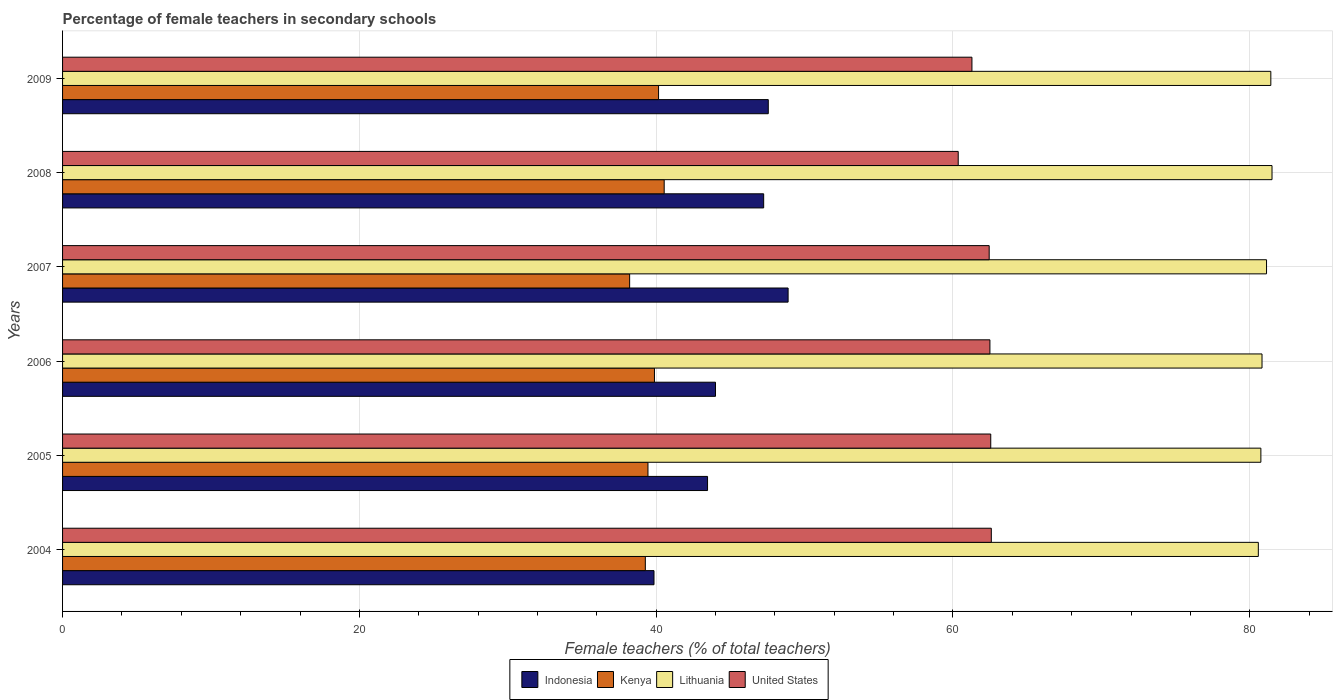How many groups of bars are there?
Give a very brief answer. 6. Are the number of bars per tick equal to the number of legend labels?
Provide a succinct answer. Yes. How many bars are there on the 4th tick from the top?
Your answer should be compact. 4. What is the label of the 1st group of bars from the top?
Provide a succinct answer. 2009. In how many cases, is the number of bars for a given year not equal to the number of legend labels?
Ensure brevity in your answer.  0. What is the percentage of female teachers in Lithuania in 2005?
Offer a terse response. 80.75. Across all years, what is the maximum percentage of female teachers in Lithuania?
Offer a terse response. 81.5. Across all years, what is the minimum percentage of female teachers in United States?
Your response must be concise. 60.36. In which year was the percentage of female teachers in Indonesia minimum?
Give a very brief answer. 2004. What is the total percentage of female teachers in Lithuania in the graph?
Make the answer very short. 486.22. What is the difference between the percentage of female teachers in Kenya in 2004 and that in 2007?
Provide a succinct answer. 1.06. What is the difference between the percentage of female teachers in Lithuania in 2006 and the percentage of female teachers in Indonesia in 2008?
Your response must be concise. 33.58. What is the average percentage of female teachers in Kenya per year?
Offer a terse response. 39.59. In the year 2009, what is the difference between the percentage of female teachers in Indonesia and percentage of female teachers in United States?
Make the answer very short. -13.72. What is the ratio of the percentage of female teachers in Kenya in 2006 to that in 2008?
Keep it short and to the point. 0.98. What is the difference between the highest and the second highest percentage of female teachers in Kenya?
Your answer should be compact. 0.38. What is the difference between the highest and the lowest percentage of female teachers in Lithuania?
Your answer should be compact. 0.92. In how many years, is the percentage of female teachers in Kenya greater than the average percentage of female teachers in Kenya taken over all years?
Provide a succinct answer. 3. Is the sum of the percentage of female teachers in Indonesia in 2007 and 2008 greater than the maximum percentage of female teachers in Kenya across all years?
Offer a very short reply. Yes. What does the 2nd bar from the top in 2009 represents?
Your answer should be compact. Lithuania. How many bars are there?
Offer a terse response. 24. Are all the bars in the graph horizontal?
Offer a terse response. Yes. How many years are there in the graph?
Your answer should be very brief. 6. Are the values on the major ticks of X-axis written in scientific E-notation?
Make the answer very short. No. Does the graph contain grids?
Keep it short and to the point. Yes. Where does the legend appear in the graph?
Offer a terse response. Bottom center. How are the legend labels stacked?
Provide a succinct answer. Horizontal. What is the title of the graph?
Make the answer very short. Percentage of female teachers in secondary schools. Does "Greenland" appear as one of the legend labels in the graph?
Provide a succinct answer. No. What is the label or title of the X-axis?
Your response must be concise. Female teachers (% of total teachers). What is the Female teachers (% of total teachers) in Indonesia in 2004?
Offer a very short reply. 39.86. What is the Female teachers (% of total teachers) in Kenya in 2004?
Your response must be concise. 39.27. What is the Female teachers (% of total teachers) in Lithuania in 2004?
Make the answer very short. 80.58. What is the Female teachers (% of total teachers) of United States in 2004?
Offer a very short reply. 62.59. What is the Female teachers (% of total teachers) of Indonesia in 2005?
Keep it short and to the point. 43.46. What is the Female teachers (% of total teachers) of Kenya in 2005?
Your answer should be compact. 39.45. What is the Female teachers (% of total teachers) in Lithuania in 2005?
Give a very brief answer. 80.75. What is the Female teachers (% of total teachers) of United States in 2005?
Your answer should be compact. 62.55. What is the Female teachers (% of total teachers) in Indonesia in 2006?
Ensure brevity in your answer.  44. What is the Female teachers (% of total teachers) of Kenya in 2006?
Give a very brief answer. 39.89. What is the Female teachers (% of total teachers) of Lithuania in 2006?
Make the answer very short. 80.83. What is the Female teachers (% of total teachers) of United States in 2006?
Provide a succinct answer. 62.49. What is the Female teachers (% of total teachers) of Indonesia in 2007?
Give a very brief answer. 48.89. What is the Female teachers (% of total teachers) of Kenya in 2007?
Your answer should be compact. 38.21. What is the Female teachers (% of total teachers) of Lithuania in 2007?
Ensure brevity in your answer.  81.13. What is the Female teachers (% of total teachers) of United States in 2007?
Keep it short and to the point. 62.44. What is the Female teachers (% of total teachers) in Indonesia in 2008?
Offer a very short reply. 47.25. What is the Female teachers (% of total teachers) in Kenya in 2008?
Give a very brief answer. 40.54. What is the Female teachers (% of total teachers) in Lithuania in 2008?
Provide a succinct answer. 81.5. What is the Female teachers (% of total teachers) in United States in 2008?
Keep it short and to the point. 60.36. What is the Female teachers (% of total teachers) in Indonesia in 2009?
Provide a succinct answer. 47.56. What is the Female teachers (% of total teachers) of Kenya in 2009?
Your answer should be very brief. 40.16. What is the Female teachers (% of total teachers) in Lithuania in 2009?
Offer a very short reply. 81.42. What is the Female teachers (% of total teachers) of United States in 2009?
Ensure brevity in your answer.  61.28. Across all years, what is the maximum Female teachers (% of total teachers) in Indonesia?
Your answer should be very brief. 48.89. Across all years, what is the maximum Female teachers (% of total teachers) of Kenya?
Provide a succinct answer. 40.54. Across all years, what is the maximum Female teachers (% of total teachers) in Lithuania?
Offer a terse response. 81.5. Across all years, what is the maximum Female teachers (% of total teachers) of United States?
Keep it short and to the point. 62.59. Across all years, what is the minimum Female teachers (% of total teachers) of Indonesia?
Offer a very short reply. 39.86. Across all years, what is the minimum Female teachers (% of total teachers) in Kenya?
Provide a short and direct response. 38.21. Across all years, what is the minimum Female teachers (% of total teachers) in Lithuania?
Your response must be concise. 80.58. Across all years, what is the minimum Female teachers (% of total teachers) in United States?
Provide a succinct answer. 60.36. What is the total Female teachers (% of total teachers) of Indonesia in the graph?
Your answer should be compact. 271.02. What is the total Female teachers (% of total teachers) of Kenya in the graph?
Offer a terse response. 237.53. What is the total Female teachers (% of total teachers) of Lithuania in the graph?
Ensure brevity in your answer.  486.22. What is the total Female teachers (% of total teachers) of United States in the graph?
Provide a succinct answer. 371.71. What is the difference between the Female teachers (% of total teachers) in Indonesia in 2004 and that in 2005?
Offer a terse response. -3.61. What is the difference between the Female teachers (% of total teachers) in Kenya in 2004 and that in 2005?
Provide a succinct answer. -0.18. What is the difference between the Female teachers (% of total teachers) in Lithuania in 2004 and that in 2005?
Offer a very short reply. -0.17. What is the difference between the Female teachers (% of total teachers) in United States in 2004 and that in 2005?
Offer a terse response. 0.04. What is the difference between the Female teachers (% of total teachers) in Indonesia in 2004 and that in 2006?
Your response must be concise. -4.14. What is the difference between the Female teachers (% of total teachers) of Kenya in 2004 and that in 2006?
Offer a very short reply. -0.61. What is the difference between the Female teachers (% of total teachers) in Lithuania in 2004 and that in 2006?
Your answer should be very brief. -0.25. What is the difference between the Female teachers (% of total teachers) of United States in 2004 and that in 2006?
Offer a very short reply. 0.09. What is the difference between the Female teachers (% of total teachers) of Indonesia in 2004 and that in 2007?
Your answer should be compact. -9.04. What is the difference between the Female teachers (% of total teachers) in Kenya in 2004 and that in 2007?
Offer a terse response. 1.06. What is the difference between the Female teachers (% of total teachers) in Lithuania in 2004 and that in 2007?
Ensure brevity in your answer.  -0.55. What is the difference between the Female teachers (% of total teachers) in United States in 2004 and that in 2007?
Make the answer very short. 0.14. What is the difference between the Female teachers (% of total teachers) of Indonesia in 2004 and that in 2008?
Make the answer very short. -7.39. What is the difference between the Female teachers (% of total teachers) of Kenya in 2004 and that in 2008?
Provide a succinct answer. -1.27. What is the difference between the Female teachers (% of total teachers) in Lithuania in 2004 and that in 2008?
Your answer should be very brief. -0.92. What is the difference between the Female teachers (% of total teachers) in United States in 2004 and that in 2008?
Offer a terse response. 2.23. What is the difference between the Female teachers (% of total teachers) in Indonesia in 2004 and that in 2009?
Give a very brief answer. -7.7. What is the difference between the Female teachers (% of total teachers) in Kenya in 2004 and that in 2009?
Offer a terse response. -0.89. What is the difference between the Female teachers (% of total teachers) of Lithuania in 2004 and that in 2009?
Offer a terse response. -0.84. What is the difference between the Female teachers (% of total teachers) in United States in 2004 and that in 2009?
Offer a very short reply. 1.31. What is the difference between the Female teachers (% of total teachers) in Indonesia in 2005 and that in 2006?
Give a very brief answer. -0.54. What is the difference between the Female teachers (% of total teachers) in Kenya in 2005 and that in 2006?
Your answer should be compact. -0.44. What is the difference between the Female teachers (% of total teachers) in Lithuania in 2005 and that in 2006?
Keep it short and to the point. -0.08. What is the difference between the Female teachers (% of total teachers) in United States in 2005 and that in 2006?
Ensure brevity in your answer.  0.06. What is the difference between the Female teachers (% of total teachers) of Indonesia in 2005 and that in 2007?
Your response must be concise. -5.43. What is the difference between the Female teachers (% of total teachers) in Kenya in 2005 and that in 2007?
Your response must be concise. 1.24. What is the difference between the Female teachers (% of total teachers) in Lithuania in 2005 and that in 2007?
Ensure brevity in your answer.  -0.38. What is the difference between the Female teachers (% of total teachers) in United States in 2005 and that in 2007?
Make the answer very short. 0.1. What is the difference between the Female teachers (% of total teachers) in Indonesia in 2005 and that in 2008?
Give a very brief answer. -3.78. What is the difference between the Female teachers (% of total teachers) in Kenya in 2005 and that in 2008?
Your response must be concise. -1.09. What is the difference between the Female teachers (% of total teachers) of Lithuania in 2005 and that in 2008?
Provide a succinct answer. -0.75. What is the difference between the Female teachers (% of total teachers) in United States in 2005 and that in 2008?
Your answer should be very brief. 2.19. What is the difference between the Female teachers (% of total teachers) of Indonesia in 2005 and that in 2009?
Your answer should be very brief. -4.09. What is the difference between the Female teachers (% of total teachers) of Kenya in 2005 and that in 2009?
Provide a succinct answer. -0.71. What is the difference between the Female teachers (% of total teachers) of Lithuania in 2005 and that in 2009?
Ensure brevity in your answer.  -0.67. What is the difference between the Female teachers (% of total teachers) of United States in 2005 and that in 2009?
Your answer should be very brief. 1.27. What is the difference between the Female teachers (% of total teachers) of Indonesia in 2006 and that in 2007?
Give a very brief answer. -4.89. What is the difference between the Female teachers (% of total teachers) in Kenya in 2006 and that in 2007?
Provide a short and direct response. 1.67. What is the difference between the Female teachers (% of total teachers) of Lithuania in 2006 and that in 2007?
Your answer should be very brief. -0.3. What is the difference between the Female teachers (% of total teachers) in United States in 2006 and that in 2007?
Your response must be concise. 0.05. What is the difference between the Female teachers (% of total teachers) of Indonesia in 2006 and that in 2008?
Your answer should be compact. -3.25. What is the difference between the Female teachers (% of total teachers) in Kenya in 2006 and that in 2008?
Offer a very short reply. -0.66. What is the difference between the Female teachers (% of total teachers) of Lithuania in 2006 and that in 2008?
Your answer should be compact. -0.67. What is the difference between the Female teachers (% of total teachers) in United States in 2006 and that in 2008?
Ensure brevity in your answer.  2.14. What is the difference between the Female teachers (% of total teachers) of Indonesia in 2006 and that in 2009?
Provide a short and direct response. -3.56. What is the difference between the Female teachers (% of total teachers) in Kenya in 2006 and that in 2009?
Keep it short and to the point. -0.28. What is the difference between the Female teachers (% of total teachers) in Lithuania in 2006 and that in 2009?
Keep it short and to the point. -0.59. What is the difference between the Female teachers (% of total teachers) in United States in 2006 and that in 2009?
Your answer should be compact. 1.21. What is the difference between the Female teachers (% of total teachers) in Indonesia in 2007 and that in 2008?
Make the answer very short. 1.65. What is the difference between the Female teachers (% of total teachers) of Kenya in 2007 and that in 2008?
Keep it short and to the point. -2.33. What is the difference between the Female teachers (% of total teachers) in Lithuania in 2007 and that in 2008?
Provide a succinct answer. -0.37. What is the difference between the Female teachers (% of total teachers) of United States in 2007 and that in 2008?
Make the answer very short. 2.09. What is the difference between the Female teachers (% of total teachers) of Indonesia in 2007 and that in 2009?
Provide a short and direct response. 1.34. What is the difference between the Female teachers (% of total teachers) of Kenya in 2007 and that in 2009?
Your response must be concise. -1.95. What is the difference between the Female teachers (% of total teachers) of Lithuania in 2007 and that in 2009?
Ensure brevity in your answer.  -0.29. What is the difference between the Female teachers (% of total teachers) in United States in 2007 and that in 2009?
Offer a very short reply. 1.16. What is the difference between the Female teachers (% of total teachers) of Indonesia in 2008 and that in 2009?
Keep it short and to the point. -0.31. What is the difference between the Female teachers (% of total teachers) of Kenya in 2008 and that in 2009?
Offer a terse response. 0.38. What is the difference between the Female teachers (% of total teachers) in Lithuania in 2008 and that in 2009?
Offer a terse response. 0.08. What is the difference between the Female teachers (% of total teachers) in United States in 2008 and that in 2009?
Your answer should be very brief. -0.93. What is the difference between the Female teachers (% of total teachers) of Indonesia in 2004 and the Female teachers (% of total teachers) of Kenya in 2005?
Your response must be concise. 0.41. What is the difference between the Female teachers (% of total teachers) of Indonesia in 2004 and the Female teachers (% of total teachers) of Lithuania in 2005?
Provide a short and direct response. -40.9. What is the difference between the Female teachers (% of total teachers) in Indonesia in 2004 and the Female teachers (% of total teachers) in United States in 2005?
Your answer should be very brief. -22.69. What is the difference between the Female teachers (% of total teachers) of Kenya in 2004 and the Female teachers (% of total teachers) of Lithuania in 2005?
Make the answer very short. -41.48. What is the difference between the Female teachers (% of total teachers) of Kenya in 2004 and the Female teachers (% of total teachers) of United States in 2005?
Provide a short and direct response. -23.28. What is the difference between the Female teachers (% of total teachers) of Lithuania in 2004 and the Female teachers (% of total teachers) of United States in 2005?
Make the answer very short. 18.03. What is the difference between the Female teachers (% of total teachers) in Indonesia in 2004 and the Female teachers (% of total teachers) in Kenya in 2006?
Keep it short and to the point. -0.03. What is the difference between the Female teachers (% of total teachers) of Indonesia in 2004 and the Female teachers (% of total teachers) of Lithuania in 2006?
Ensure brevity in your answer.  -40.97. What is the difference between the Female teachers (% of total teachers) of Indonesia in 2004 and the Female teachers (% of total teachers) of United States in 2006?
Offer a very short reply. -22.64. What is the difference between the Female teachers (% of total teachers) of Kenya in 2004 and the Female teachers (% of total teachers) of Lithuania in 2006?
Make the answer very short. -41.56. What is the difference between the Female teachers (% of total teachers) of Kenya in 2004 and the Female teachers (% of total teachers) of United States in 2006?
Your answer should be compact. -23.22. What is the difference between the Female teachers (% of total teachers) of Lithuania in 2004 and the Female teachers (% of total teachers) of United States in 2006?
Your response must be concise. 18.09. What is the difference between the Female teachers (% of total teachers) of Indonesia in 2004 and the Female teachers (% of total teachers) of Kenya in 2007?
Give a very brief answer. 1.64. What is the difference between the Female teachers (% of total teachers) in Indonesia in 2004 and the Female teachers (% of total teachers) in Lithuania in 2007?
Offer a terse response. -41.28. What is the difference between the Female teachers (% of total teachers) in Indonesia in 2004 and the Female teachers (% of total teachers) in United States in 2007?
Your answer should be compact. -22.59. What is the difference between the Female teachers (% of total teachers) in Kenya in 2004 and the Female teachers (% of total teachers) in Lithuania in 2007?
Provide a succinct answer. -41.86. What is the difference between the Female teachers (% of total teachers) in Kenya in 2004 and the Female teachers (% of total teachers) in United States in 2007?
Offer a very short reply. -23.17. What is the difference between the Female teachers (% of total teachers) in Lithuania in 2004 and the Female teachers (% of total teachers) in United States in 2007?
Offer a terse response. 18.14. What is the difference between the Female teachers (% of total teachers) in Indonesia in 2004 and the Female teachers (% of total teachers) in Kenya in 2008?
Give a very brief answer. -0.69. What is the difference between the Female teachers (% of total teachers) of Indonesia in 2004 and the Female teachers (% of total teachers) of Lithuania in 2008?
Offer a very short reply. -41.65. What is the difference between the Female teachers (% of total teachers) of Indonesia in 2004 and the Female teachers (% of total teachers) of United States in 2008?
Your answer should be compact. -20.5. What is the difference between the Female teachers (% of total teachers) of Kenya in 2004 and the Female teachers (% of total teachers) of Lithuania in 2008?
Offer a terse response. -42.23. What is the difference between the Female teachers (% of total teachers) of Kenya in 2004 and the Female teachers (% of total teachers) of United States in 2008?
Keep it short and to the point. -21.09. What is the difference between the Female teachers (% of total teachers) in Lithuania in 2004 and the Female teachers (% of total teachers) in United States in 2008?
Offer a terse response. 20.22. What is the difference between the Female teachers (% of total teachers) of Indonesia in 2004 and the Female teachers (% of total teachers) of Kenya in 2009?
Your response must be concise. -0.31. What is the difference between the Female teachers (% of total teachers) in Indonesia in 2004 and the Female teachers (% of total teachers) in Lithuania in 2009?
Provide a succinct answer. -41.57. What is the difference between the Female teachers (% of total teachers) of Indonesia in 2004 and the Female teachers (% of total teachers) of United States in 2009?
Provide a short and direct response. -21.43. What is the difference between the Female teachers (% of total teachers) of Kenya in 2004 and the Female teachers (% of total teachers) of Lithuania in 2009?
Ensure brevity in your answer.  -42.15. What is the difference between the Female teachers (% of total teachers) in Kenya in 2004 and the Female teachers (% of total teachers) in United States in 2009?
Your answer should be compact. -22.01. What is the difference between the Female teachers (% of total teachers) of Lithuania in 2004 and the Female teachers (% of total teachers) of United States in 2009?
Offer a very short reply. 19.3. What is the difference between the Female teachers (% of total teachers) of Indonesia in 2005 and the Female teachers (% of total teachers) of Kenya in 2006?
Ensure brevity in your answer.  3.58. What is the difference between the Female teachers (% of total teachers) of Indonesia in 2005 and the Female teachers (% of total teachers) of Lithuania in 2006?
Provide a succinct answer. -37.36. What is the difference between the Female teachers (% of total teachers) of Indonesia in 2005 and the Female teachers (% of total teachers) of United States in 2006?
Give a very brief answer. -19.03. What is the difference between the Female teachers (% of total teachers) in Kenya in 2005 and the Female teachers (% of total teachers) in Lithuania in 2006?
Provide a short and direct response. -41.38. What is the difference between the Female teachers (% of total teachers) of Kenya in 2005 and the Female teachers (% of total teachers) of United States in 2006?
Provide a short and direct response. -23.04. What is the difference between the Female teachers (% of total teachers) in Lithuania in 2005 and the Female teachers (% of total teachers) in United States in 2006?
Provide a succinct answer. 18.26. What is the difference between the Female teachers (% of total teachers) in Indonesia in 2005 and the Female teachers (% of total teachers) in Kenya in 2007?
Ensure brevity in your answer.  5.25. What is the difference between the Female teachers (% of total teachers) of Indonesia in 2005 and the Female teachers (% of total teachers) of Lithuania in 2007?
Your response must be concise. -37.67. What is the difference between the Female teachers (% of total teachers) of Indonesia in 2005 and the Female teachers (% of total teachers) of United States in 2007?
Keep it short and to the point. -18.98. What is the difference between the Female teachers (% of total teachers) in Kenya in 2005 and the Female teachers (% of total teachers) in Lithuania in 2007?
Provide a short and direct response. -41.68. What is the difference between the Female teachers (% of total teachers) of Kenya in 2005 and the Female teachers (% of total teachers) of United States in 2007?
Provide a short and direct response. -22.99. What is the difference between the Female teachers (% of total teachers) in Lithuania in 2005 and the Female teachers (% of total teachers) in United States in 2007?
Make the answer very short. 18.31. What is the difference between the Female teachers (% of total teachers) in Indonesia in 2005 and the Female teachers (% of total teachers) in Kenya in 2008?
Provide a short and direct response. 2.92. What is the difference between the Female teachers (% of total teachers) of Indonesia in 2005 and the Female teachers (% of total teachers) of Lithuania in 2008?
Provide a succinct answer. -38.04. What is the difference between the Female teachers (% of total teachers) in Indonesia in 2005 and the Female teachers (% of total teachers) in United States in 2008?
Offer a terse response. -16.89. What is the difference between the Female teachers (% of total teachers) of Kenya in 2005 and the Female teachers (% of total teachers) of Lithuania in 2008?
Your answer should be compact. -42.05. What is the difference between the Female teachers (% of total teachers) in Kenya in 2005 and the Female teachers (% of total teachers) in United States in 2008?
Offer a very short reply. -20.91. What is the difference between the Female teachers (% of total teachers) of Lithuania in 2005 and the Female teachers (% of total teachers) of United States in 2008?
Make the answer very short. 20.4. What is the difference between the Female teachers (% of total teachers) in Indonesia in 2005 and the Female teachers (% of total teachers) in Kenya in 2009?
Keep it short and to the point. 3.3. What is the difference between the Female teachers (% of total teachers) in Indonesia in 2005 and the Female teachers (% of total teachers) in Lithuania in 2009?
Give a very brief answer. -37.96. What is the difference between the Female teachers (% of total teachers) of Indonesia in 2005 and the Female teachers (% of total teachers) of United States in 2009?
Provide a short and direct response. -17.82. What is the difference between the Female teachers (% of total teachers) of Kenya in 2005 and the Female teachers (% of total teachers) of Lithuania in 2009?
Your answer should be very brief. -41.97. What is the difference between the Female teachers (% of total teachers) in Kenya in 2005 and the Female teachers (% of total teachers) in United States in 2009?
Offer a very short reply. -21.83. What is the difference between the Female teachers (% of total teachers) of Lithuania in 2005 and the Female teachers (% of total teachers) of United States in 2009?
Your answer should be very brief. 19.47. What is the difference between the Female teachers (% of total teachers) in Indonesia in 2006 and the Female teachers (% of total teachers) in Kenya in 2007?
Your response must be concise. 5.79. What is the difference between the Female teachers (% of total teachers) of Indonesia in 2006 and the Female teachers (% of total teachers) of Lithuania in 2007?
Give a very brief answer. -37.13. What is the difference between the Female teachers (% of total teachers) in Indonesia in 2006 and the Female teachers (% of total teachers) in United States in 2007?
Make the answer very short. -18.44. What is the difference between the Female teachers (% of total teachers) in Kenya in 2006 and the Female teachers (% of total teachers) in Lithuania in 2007?
Provide a succinct answer. -41.25. What is the difference between the Female teachers (% of total teachers) of Kenya in 2006 and the Female teachers (% of total teachers) of United States in 2007?
Provide a succinct answer. -22.56. What is the difference between the Female teachers (% of total teachers) in Lithuania in 2006 and the Female teachers (% of total teachers) in United States in 2007?
Your answer should be very brief. 18.38. What is the difference between the Female teachers (% of total teachers) of Indonesia in 2006 and the Female teachers (% of total teachers) of Kenya in 2008?
Keep it short and to the point. 3.46. What is the difference between the Female teachers (% of total teachers) of Indonesia in 2006 and the Female teachers (% of total teachers) of Lithuania in 2008?
Provide a short and direct response. -37.5. What is the difference between the Female teachers (% of total teachers) of Indonesia in 2006 and the Female teachers (% of total teachers) of United States in 2008?
Offer a terse response. -16.36. What is the difference between the Female teachers (% of total teachers) in Kenya in 2006 and the Female teachers (% of total teachers) in Lithuania in 2008?
Your answer should be compact. -41.62. What is the difference between the Female teachers (% of total teachers) in Kenya in 2006 and the Female teachers (% of total teachers) in United States in 2008?
Offer a very short reply. -20.47. What is the difference between the Female teachers (% of total teachers) of Lithuania in 2006 and the Female teachers (% of total teachers) of United States in 2008?
Make the answer very short. 20.47. What is the difference between the Female teachers (% of total teachers) in Indonesia in 2006 and the Female teachers (% of total teachers) in Kenya in 2009?
Provide a short and direct response. 3.84. What is the difference between the Female teachers (% of total teachers) in Indonesia in 2006 and the Female teachers (% of total teachers) in Lithuania in 2009?
Make the answer very short. -37.42. What is the difference between the Female teachers (% of total teachers) in Indonesia in 2006 and the Female teachers (% of total teachers) in United States in 2009?
Make the answer very short. -17.28. What is the difference between the Female teachers (% of total teachers) of Kenya in 2006 and the Female teachers (% of total teachers) of Lithuania in 2009?
Make the answer very short. -41.54. What is the difference between the Female teachers (% of total teachers) in Kenya in 2006 and the Female teachers (% of total teachers) in United States in 2009?
Give a very brief answer. -21.4. What is the difference between the Female teachers (% of total teachers) in Lithuania in 2006 and the Female teachers (% of total teachers) in United States in 2009?
Your response must be concise. 19.55. What is the difference between the Female teachers (% of total teachers) in Indonesia in 2007 and the Female teachers (% of total teachers) in Kenya in 2008?
Offer a terse response. 8.35. What is the difference between the Female teachers (% of total teachers) of Indonesia in 2007 and the Female teachers (% of total teachers) of Lithuania in 2008?
Your answer should be very brief. -32.61. What is the difference between the Female teachers (% of total teachers) in Indonesia in 2007 and the Female teachers (% of total teachers) in United States in 2008?
Ensure brevity in your answer.  -11.46. What is the difference between the Female teachers (% of total teachers) of Kenya in 2007 and the Female teachers (% of total teachers) of Lithuania in 2008?
Your answer should be compact. -43.29. What is the difference between the Female teachers (% of total teachers) of Kenya in 2007 and the Female teachers (% of total teachers) of United States in 2008?
Your response must be concise. -22.14. What is the difference between the Female teachers (% of total teachers) of Lithuania in 2007 and the Female teachers (% of total teachers) of United States in 2008?
Your answer should be compact. 20.78. What is the difference between the Female teachers (% of total teachers) of Indonesia in 2007 and the Female teachers (% of total teachers) of Kenya in 2009?
Offer a very short reply. 8.73. What is the difference between the Female teachers (% of total teachers) of Indonesia in 2007 and the Female teachers (% of total teachers) of Lithuania in 2009?
Give a very brief answer. -32.53. What is the difference between the Female teachers (% of total teachers) in Indonesia in 2007 and the Female teachers (% of total teachers) in United States in 2009?
Give a very brief answer. -12.39. What is the difference between the Female teachers (% of total teachers) in Kenya in 2007 and the Female teachers (% of total teachers) in Lithuania in 2009?
Provide a succinct answer. -43.21. What is the difference between the Female teachers (% of total teachers) in Kenya in 2007 and the Female teachers (% of total teachers) in United States in 2009?
Your answer should be compact. -23.07. What is the difference between the Female teachers (% of total teachers) in Lithuania in 2007 and the Female teachers (% of total teachers) in United States in 2009?
Give a very brief answer. 19.85. What is the difference between the Female teachers (% of total teachers) of Indonesia in 2008 and the Female teachers (% of total teachers) of Kenya in 2009?
Make the answer very short. 7.08. What is the difference between the Female teachers (% of total teachers) in Indonesia in 2008 and the Female teachers (% of total teachers) in Lithuania in 2009?
Your response must be concise. -34.18. What is the difference between the Female teachers (% of total teachers) in Indonesia in 2008 and the Female teachers (% of total teachers) in United States in 2009?
Provide a succinct answer. -14.03. What is the difference between the Female teachers (% of total teachers) in Kenya in 2008 and the Female teachers (% of total teachers) in Lithuania in 2009?
Your response must be concise. -40.88. What is the difference between the Female teachers (% of total teachers) in Kenya in 2008 and the Female teachers (% of total teachers) in United States in 2009?
Keep it short and to the point. -20.74. What is the difference between the Female teachers (% of total teachers) of Lithuania in 2008 and the Female teachers (% of total teachers) of United States in 2009?
Keep it short and to the point. 20.22. What is the average Female teachers (% of total teachers) of Indonesia per year?
Your answer should be compact. 45.17. What is the average Female teachers (% of total teachers) of Kenya per year?
Ensure brevity in your answer.  39.59. What is the average Female teachers (% of total teachers) of Lithuania per year?
Provide a succinct answer. 81.04. What is the average Female teachers (% of total teachers) in United States per year?
Offer a terse response. 61.95. In the year 2004, what is the difference between the Female teachers (% of total teachers) in Indonesia and Female teachers (% of total teachers) in Kenya?
Your answer should be compact. 0.58. In the year 2004, what is the difference between the Female teachers (% of total teachers) of Indonesia and Female teachers (% of total teachers) of Lithuania?
Your answer should be compact. -40.73. In the year 2004, what is the difference between the Female teachers (% of total teachers) in Indonesia and Female teachers (% of total teachers) in United States?
Your response must be concise. -22.73. In the year 2004, what is the difference between the Female teachers (% of total teachers) in Kenya and Female teachers (% of total teachers) in Lithuania?
Your answer should be very brief. -41.31. In the year 2004, what is the difference between the Female teachers (% of total teachers) of Kenya and Female teachers (% of total teachers) of United States?
Your answer should be very brief. -23.32. In the year 2004, what is the difference between the Female teachers (% of total teachers) of Lithuania and Female teachers (% of total teachers) of United States?
Give a very brief answer. 17.99. In the year 2005, what is the difference between the Female teachers (% of total teachers) in Indonesia and Female teachers (% of total teachers) in Kenya?
Your response must be concise. 4.01. In the year 2005, what is the difference between the Female teachers (% of total teachers) in Indonesia and Female teachers (% of total teachers) in Lithuania?
Offer a very short reply. -37.29. In the year 2005, what is the difference between the Female teachers (% of total teachers) in Indonesia and Female teachers (% of total teachers) in United States?
Ensure brevity in your answer.  -19.08. In the year 2005, what is the difference between the Female teachers (% of total teachers) of Kenya and Female teachers (% of total teachers) of Lithuania?
Your answer should be compact. -41.3. In the year 2005, what is the difference between the Female teachers (% of total teachers) of Kenya and Female teachers (% of total teachers) of United States?
Provide a short and direct response. -23.1. In the year 2005, what is the difference between the Female teachers (% of total teachers) of Lithuania and Female teachers (% of total teachers) of United States?
Make the answer very short. 18.2. In the year 2006, what is the difference between the Female teachers (% of total teachers) of Indonesia and Female teachers (% of total teachers) of Kenya?
Your answer should be compact. 4.11. In the year 2006, what is the difference between the Female teachers (% of total teachers) in Indonesia and Female teachers (% of total teachers) in Lithuania?
Your answer should be very brief. -36.83. In the year 2006, what is the difference between the Female teachers (% of total teachers) in Indonesia and Female teachers (% of total teachers) in United States?
Provide a short and direct response. -18.49. In the year 2006, what is the difference between the Female teachers (% of total teachers) of Kenya and Female teachers (% of total teachers) of Lithuania?
Provide a short and direct response. -40.94. In the year 2006, what is the difference between the Female teachers (% of total teachers) of Kenya and Female teachers (% of total teachers) of United States?
Ensure brevity in your answer.  -22.61. In the year 2006, what is the difference between the Female teachers (% of total teachers) of Lithuania and Female teachers (% of total teachers) of United States?
Make the answer very short. 18.34. In the year 2007, what is the difference between the Female teachers (% of total teachers) of Indonesia and Female teachers (% of total teachers) of Kenya?
Give a very brief answer. 10.68. In the year 2007, what is the difference between the Female teachers (% of total teachers) in Indonesia and Female teachers (% of total teachers) in Lithuania?
Provide a succinct answer. -32.24. In the year 2007, what is the difference between the Female teachers (% of total teachers) in Indonesia and Female teachers (% of total teachers) in United States?
Your response must be concise. -13.55. In the year 2007, what is the difference between the Female teachers (% of total teachers) in Kenya and Female teachers (% of total teachers) in Lithuania?
Provide a succinct answer. -42.92. In the year 2007, what is the difference between the Female teachers (% of total teachers) in Kenya and Female teachers (% of total teachers) in United States?
Offer a terse response. -24.23. In the year 2007, what is the difference between the Female teachers (% of total teachers) in Lithuania and Female teachers (% of total teachers) in United States?
Your answer should be very brief. 18.69. In the year 2008, what is the difference between the Female teachers (% of total teachers) of Indonesia and Female teachers (% of total teachers) of Kenya?
Ensure brevity in your answer.  6.7. In the year 2008, what is the difference between the Female teachers (% of total teachers) of Indonesia and Female teachers (% of total teachers) of Lithuania?
Your response must be concise. -34.26. In the year 2008, what is the difference between the Female teachers (% of total teachers) of Indonesia and Female teachers (% of total teachers) of United States?
Your response must be concise. -13.11. In the year 2008, what is the difference between the Female teachers (% of total teachers) of Kenya and Female teachers (% of total teachers) of Lithuania?
Ensure brevity in your answer.  -40.96. In the year 2008, what is the difference between the Female teachers (% of total teachers) of Kenya and Female teachers (% of total teachers) of United States?
Provide a succinct answer. -19.81. In the year 2008, what is the difference between the Female teachers (% of total teachers) in Lithuania and Female teachers (% of total teachers) in United States?
Your response must be concise. 21.15. In the year 2009, what is the difference between the Female teachers (% of total teachers) of Indonesia and Female teachers (% of total teachers) of Kenya?
Your answer should be compact. 7.39. In the year 2009, what is the difference between the Female teachers (% of total teachers) of Indonesia and Female teachers (% of total teachers) of Lithuania?
Your answer should be very brief. -33.87. In the year 2009, what is the difference between the Female teachers (% of total teachers) of Indonesia and Female teachers (% of total teachers) of United States?
Ensure brevity in your answer.  -13.72. In the year 2009, what is the difference between the Female teachers (% of total teachers) in Kenya and Female teachers (% of total teachers) in Lithuania?
Offer a terse response. -41.26. In the year 2009, what is the difference between the Female teachers (% of total teachers) in Kenya and Female teachers (% of total teachers) in United States?
Ensure brevity in your answer.  -21.12. In the year 2009, what is the difference between the Female teachers (% of total teachers) of Lithuania and Female teachers (% of total teachers) of United States?
Provide a succinct answer. 20.14. What is the ratio of the Female teachers (% of total teachers) in Indonesia in 2004 to that in 2005?
Make the answer very short. 0.92. What is the ratio of the Female teachers (% of total teachers) in Indonesia in 2004 to that in 2006?
Ensure brevity in your answer.  0.91. What is the ratio of the Female teachers (% of total teachers) of Kenya in 2004 to that in 2006?
Provide a short and direct response. 0.98. What is the ratio of the Female teachers (% of total teachers) in Lithuania in 2004 to that in 2006?
Provide a succinct answer. 1. What is the ratio of the Female teachers (% of total teachers) of United States in 2004 to that in 2006?
Make the answer very short. 1. What is the ratio of the Female teachers (% of total teachers) in Indonesia in 2004 to that in 2007?
Provide a short and direct response. 0.82. What is the ratio of the Female teachers (% of total teachers) of Kenya in 2004 to that in 2007?
Offer a very short reply. 1.03. What is the ratio of the Female teachers (% of total teachers) in Lithuania in 2004 to that in 2007?
Give a very brief answer. 0.99. What is the ratio of the Female teachers (% of total teachers) of United States in 2004 to that in 2007?
Ensure brevity in your answer.  1. What is the ratio of the Female teachers (% of total teachers) in Indonesia in 2004 to that in 2008?
Provide a short and direct response. 0.84. What is the ratio of the Female teachers (% of total teachers) of Kenya in 2004 to that in 2008?
Your answer should be very brief. 0.97. What is the ratio of the Female teachers (% of total teachers) of Lithuania in 2004 to that in 2008?
Offer a very short reply. 0.99. What is the ratio of the Female teachers (% of total teachers) in Indonesia in 2004 to that in 2009?
Your answer should be compact. 0.84. What is the ratio of the Female teachers (% of total teachers) in Kenya in 2004 to that in 2009?
Provide a succinct answer. 0.98. What is the ratio of the Female teachers (% of total teachers) in Lithuania in 2004 to that in 2009?
Offer a terse response. 0.99. What is the ratio of the Female teachers (% of total teachers) in United States in 2004 to that in 2009?
Your response must be concise. 1.02. What is the ratio of the Female teachers (% of total teachers) in Kenya in 2005 to that in 2006?
Your answer should be very brief. 0.99. What is the ratio of the Female teachers (% of total teachers) of United States in 2005 to that in 2006?
Give a very brief answer. 1. What is the ratio of the Female teachers (% of total teachers) of Indonesia in 2005 to that in 2007?
Offer a terse response. 0.89. What is the ratio of the Female teachers (% of total teachers) in Kenya in 2005 to that in 2007?
Keep it short and to the point. 1.03. What is the ratio of the Female teachers (% of total teachers) in Lithuania in 2005 to that in 2007?
Ensure brevity in your answer.  1. What is the ratio of the Female teachers (% of total teachers) in Indonesia in 2005 to that in 2008?
Your answer should be very brief. 0.92. What is the ratio of the Female teachers (% of total teachers) in Kenya in 2005 to that in 2008?
Offer a very short reply. 0.97. What is the ratio of the Female teachers (% of total teachers) in Lithuania in 2005 to that in 2008?
Your answer should be compact. 0.99. What is the ratio of the Female teachers (% of total teachers) of United States in 2005 to that in 2008?
Your answer should be compact. 1.04. What is the ratio of the Female teachers (% of total teachers) in Indonesia in 2005 to that in 2009?
Your answer should be very brief. 0.91. What is the ratio of the Female teachers (% of total teachers) of Kenya in 2005 to that in 2009?
Your response must be concise. 0.98. What is the ratio of the Female teachers (% of total teachers) of United States in 2005 to that in 2009?
Give a very brief answer. 1.02. What is the ratio of the Female teachers (% of total teachers) of Indonesia in 2006 to that in 2007?
Ensure brevity in your answer.  0.9. What is the ratio of the Female teachers (% of total teachers) of Kenya in 2006 to that in 2007?
Provide a short and direct response. 1.04. What is the ratio of the Female teachers (% of total teachers) of United States in 2006 to that in 2007?
Make the answer very short. 1. What is the ratio of the Female teachers (% of total teachers) of Indonesia in 2006 to that in 2008?
Give a very brief answer. 0.93. What is the ratio of the Female teachers (% of total teachers) of Kenya in 2006 to that in 2008?
Give a very brief answer. 0.98. What is the ratio of the Female teachers (% of total teachers) in Lithuania in 2006 to that in 2008?
Provide a short and direct response. 0.99. What is the ratio of the Female teachers (% of total teachers) in United States in 2006 to that in 2008?
Ensure brevity in your answer.  1.04. What is the ratio of the Female teachers (% of total teachers) in Indonesia in 2006 to that in 2009?
Provide a succinct answer. 0.93. What is the ratio of the Female teachers (% of total teachers) of United States in 2006 to that in 2009?
Provide a short and direct response. 1.02. What is the ratio of the Female teachers (% of total teachers) in Indonesia in 2007 to that in 2008?
Ensure brevity in your answer.  1.03. What is the ratio of the Female teachers (% of total teachers) in Kenya in 2007 to that in 2008?
Provide a short and direct response. 0.94. What is the ratio of the Female teachers (% of total teachers) of Lithuania in 2007 to that in 2008?
Keep it short and to the point. 1. What is the ratio of the Female teachers (% of total teachers) of United States in 2007 to that in 2008?
Keep it short and to the point. 1.03. What is the ratio of the Female teachers (% of total teachers) in Indonesia in 2007 to that in 2009?
Keep it short and to the point. 1.03. What is the ratio of the Female teachers (% of total teachers) of Kenya in 2007 to that in 2009?
Provide a short and direct response. 0.95. What is the ratio of the Female teachers (% of total teachers) in Lithuania in 2007 to that in 2009?
Your response must be concise. 1. What is the ratio of the Female teachers (% of total teachers) of Kenya in 2008 to that in 2009?
Provide a succinct answer. 1.01. What is the ratio of the Female teachers (% of total teachers) of United States in 2008 to that in 2009?
Offer a terse response. 0.98. What is the difference between the highest and the second highest Female teachers (% of total teachers) of Indonesia?
Keep it short and to the point. 1.34. What is the difference between the highest and the second highest Female teachers (% of total teachers) of Kenya?
Provide a short and direct response. 0.38. What is the difference between the highest and the second highest Female teachers (% of total teachers) in Lithuania?
Your answer should be compact. 0.08. What is the difference between the highest and the second highest Female teachers (% of total teachers) of United States?
Your response must be concise. 0.04. What is the difference between the highest and the lowest Female teachers (% of total teachers) in Indonesia?
Your answer should be compact. 9.04. What is the difference between the highest and the lowest Female teachers (% of total teachers) in Kenya?
Your answer should be compact. 2.33. What is the difference between the highest and the lowest Female teachers (% of total teachers) of Lithuania?
Your answer should be very brief. 0.92. What is the difference between the highest and the lowest Female teachers (% of total teachers) of United States?
Your answer should be very brief. 2.23. 